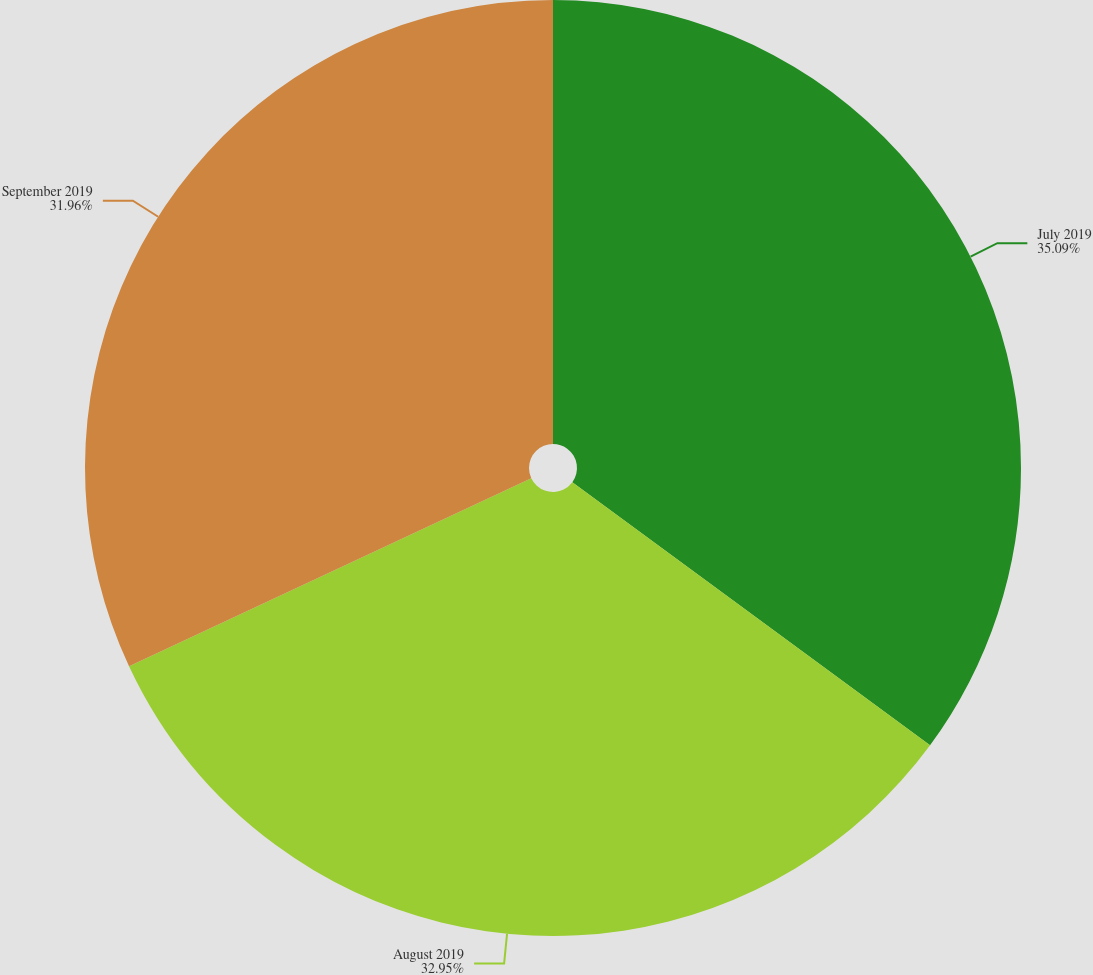<chart> <loc_0><loc_0><loc_500><loc_500><pie_chart><fcel>July 2019<fcel>August 2019<fcel>September 2019<nl><fcel>35.09%<fcel>32.95%<fcel>31.96%<nl></chart> 